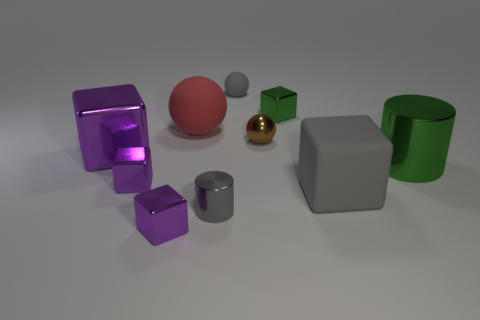Subtract all tiny cubes. How many cubes are left? 2 Subtract all red balls. How many purple blocks are left? 3 Subtract all green blocks. How many blocks are left? 4 Subtract 1 blocks. How many blocks are left? 4 Subtract all cyan balls. Subtract all red blocks. How many balls are left? 3 Subtract 1 purple blocks. How many objects are left? 9 Subtract all cylinders. How many objects are left? 8 Subtract all gray objects. Subtract all large green objects. How many objects are left? 6 Add 3 small gray shiny things. How many small gray shiny things are left? 4 Add 2 large green things. How many large green things exist? 3 